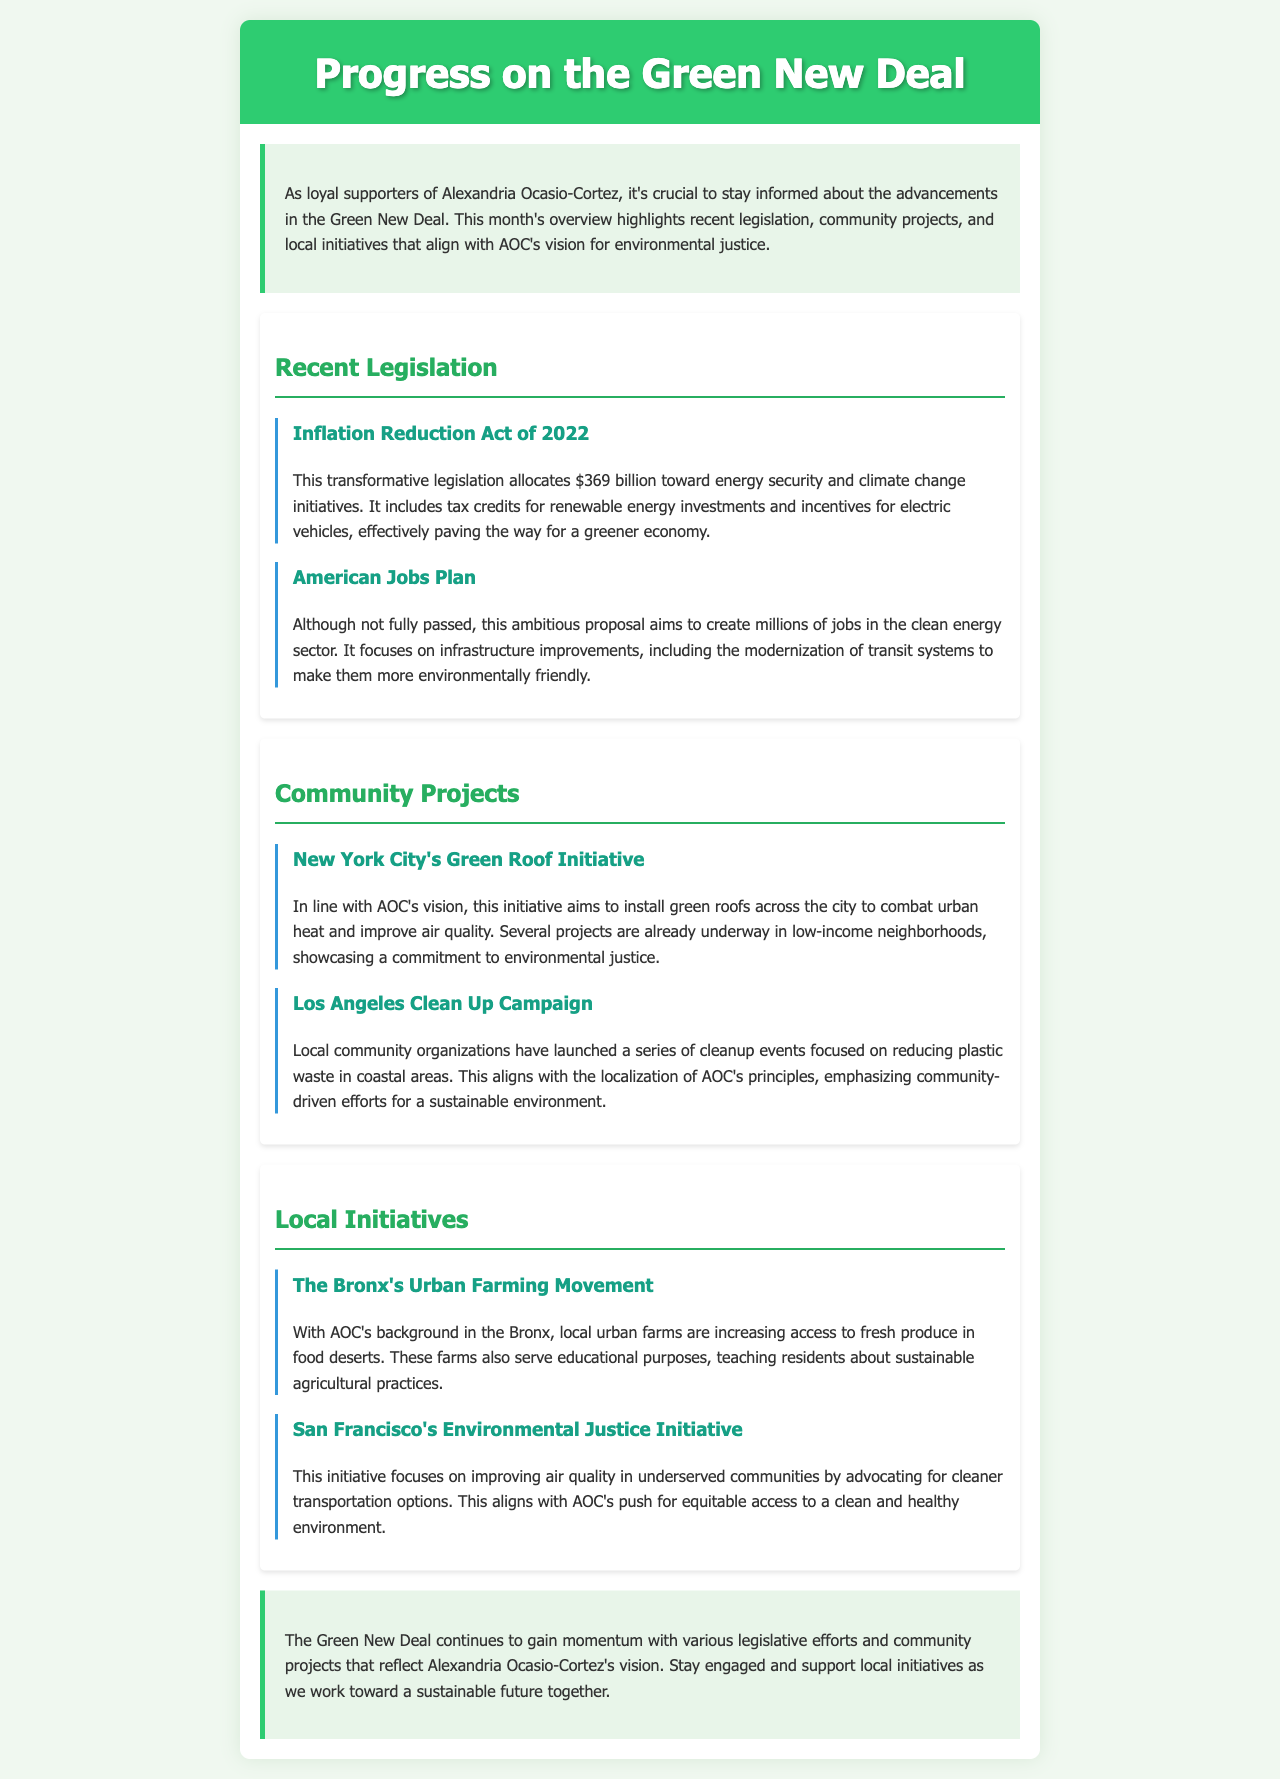What is the total allocation for the Inflation Reduction Act? The total allocation for the Inflation Reduction Act is mentioned in the document as $369 billion.
Answer: $369 billion What initiative aims to improve air quality in underserved communities? The initiative that focuses on improving air quality in underserved communities is the San Francisco's Environmental Justice Initiative.
Answer: San Francisco's Environmental Justice Initiative Which city is implementing a Green Roof Initiative? The document states that New York City is implementing a Green Roof Initiative.
Answer: New York City What is the focus of the American Jobs Plan? The focus of the American Jobs Plan includes creating millions of jobs in the clean energy sector and infrastructure improvements.
Answer: Clean energy sector jobs What type of project is being highlighted in the Los Angeles Clean Up Campaign? The type of project highlighted in the Los Angeles Clean Up Campaign is a cleanup event focused on reducing plastic waste.
Answer: Cleanup event How does the Bronx's Urban Farming Movement relate to AOC's background? The Bronx's Urban Farming Movement is relevant to AOC's background as she hails from the Bronx, connecting her to the local initiative.
Answer: AOC's background in the Bronx What color is used for the header of the newsletter? The header of the newsletter uses the color green, specifically #2ecc71.
Answer: Green What is one goal of the New York City's Green Roof Initiative? One goal of the New York City's Green Roof Initiative is to combat urban heat and improve air quality.
Answer: Combat urban heat 